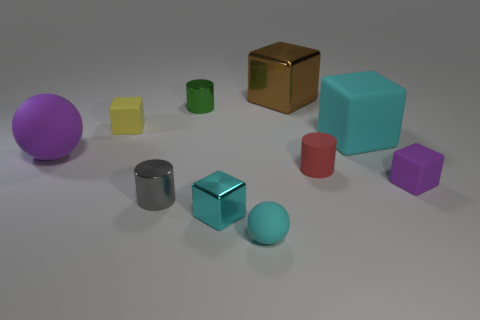Subtract all tiny red cylinders. How many cylinders are left? 2 Subtract 1 blocks. How many blocks are left? 4 Subtract 0 gray balls. How many objects are left? 10 Subtract all spheres. How many objects are left? 8 Subtract all purple cylinders. Subtract all brown blocks. How many cylinders are left? 3 Subtract all purple cylinders. How many cyan balls are left? 1 Subtract all small metal things. Subtract all green cylinders. How many objects are left? 6 Add 1 cyan metallic cubes. How many cyan metallic cubes are left? 2 Add 6 tiny yellow blocks. How many tiny yellow blocks exist? 7 Subtract all purple balls. How many balls are left? 1 